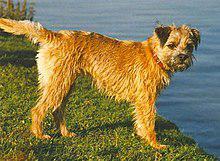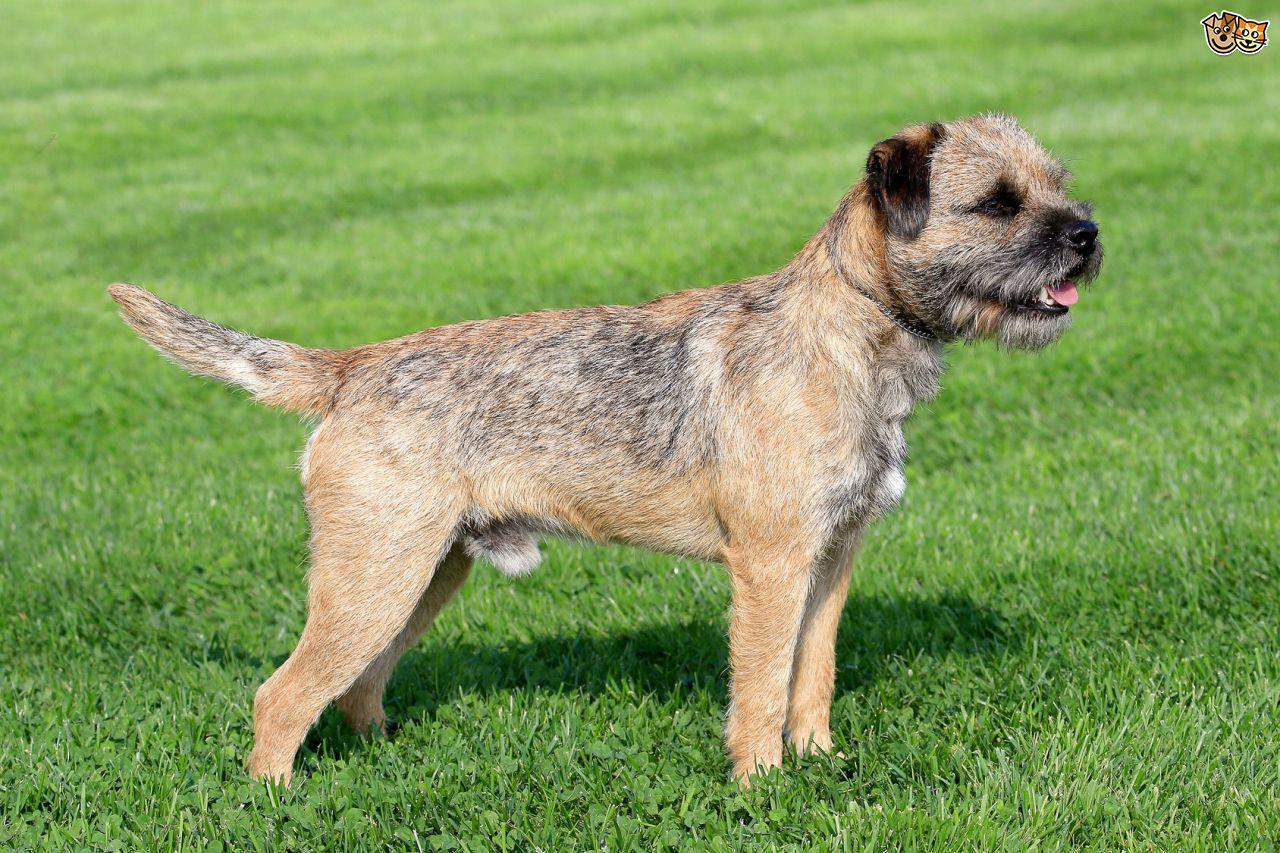The first image is the image on the left, the second image is the image on the right. For the images displayed, is the sentence "At least one image shows one dog standing on grass in profile with pointing tail." factually correct? Answer yes or no. Yes. The first image is the image on the left, the second image is the image on the right. Considering the images on both sides, is "1 of the dogs has a tail that is in a resting position." valid? Answer yes or no. No. The first image is the image on the left, the second image is the image on the right. For the images displayed, is the sentence "One dog is wearing a collar or leash, and the other dog is not." factually correct? Answer yes or no. Yes. 